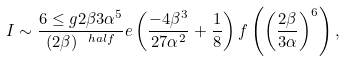Convert formula to latex. <formula><loc_0><loc_0><loc_500><loc_500>I \sim \frac { 6 \leq g { 2 \beta } { 3 \alpha } ^ { 5 } } { ( 2 \beta ) ^ { \ h a l f } } e \left ( \frac { - 4 \beta ^ { 3 } } { 2 7 \alpha ^ { 2 } } + \frac { 1 } { 8 } \right ) f \left ( \left ( \frac { 2 \beta } { 3 \alpha } \right ) ^ { 6 } \right ) ,</formula> 